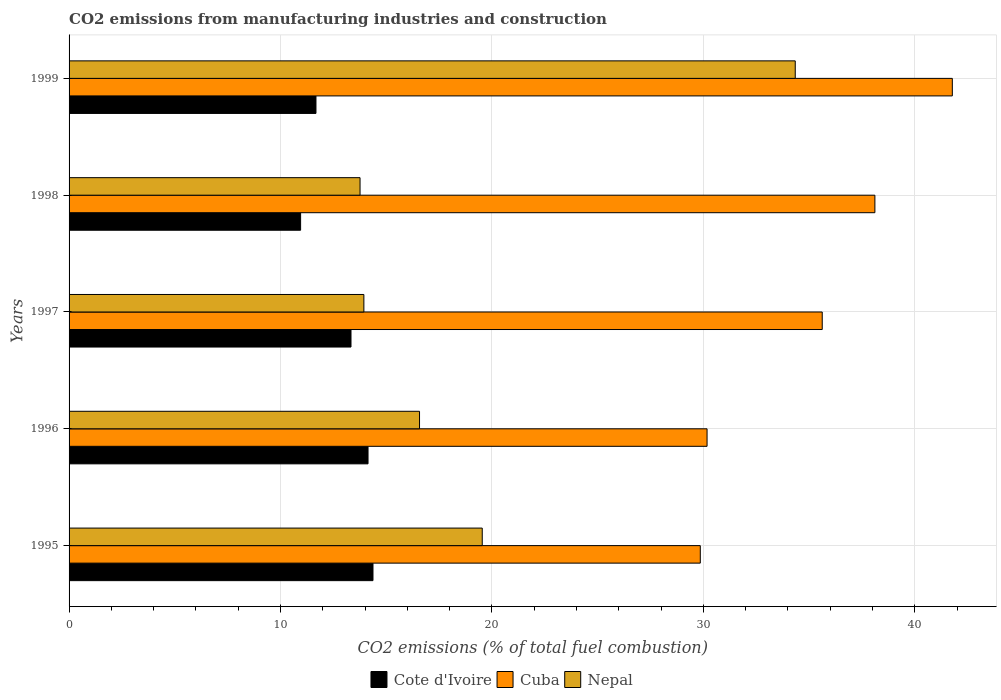How many groups of bars are there?
Give a very brief answer. 5. How many bars are there on the 3rd tick from the top?
Offer a very short reply. 3. What is the label of the 5th group of bars from the top?
Provide a succinct answer. 1995. In how many cases, is the number of bars for a given year not equal to the number of legend labels?
Provide a short and direct response. 0. What is the amount of CO2 emitted in Nepal in 1997?
Keep it short and to the point. 13.94. Across all years, what is the maximum amount of CO2 emitted in Cuba?
Provide a succinct answer. 41.77. Across all years, what is the minimum amount of CO2 emitted in Cote d'Ivoire?
Ensure brevity in your answer.  10.95. In which year was the amount of CO2 emitted in Cuba minimum?
Offer a terse response. 1995. What is the total amount of CO2 emitted in Cuba in the graph?
Provide a succinct answer. 175.53. What is the difference between the amount of CO2 emitted in Cote d'Ivoire in 1996 and that in 1999?
Provide a succinct answer. 2.46. What is the difference between the amount of CO2 emitted in Cuba in 1997 and the amount of CO2 emitted in Nepal in 1995?
Keep it short and to the point. 16.08. What is the average amount of CO2 emitted in Cote d'Ivoire per year?
Make the answer very short. 12.89. In the year 1995, what is the difference between the amount of CO2 emitted in Nepal and amount of CO2 emitted in Cote d'Ivoire?
Offer a terse response. 5.17. What is the ratio of the amount of CO2 emitted in Nepal in 1998 to that in 1999?
Offer a terse response. 0.4. Is the amount of CO2 emitted in Cuba in 1996 less than that in 1997?
Ensure brevity in your answer.  Yes. What is the difference between the highest and the second highest amount of CO2 emitted in Cuba?
Offer a very short reply. 3.66. What is the difference between the highest and the lowest amount of CO2 emitted in Nepal?
Provide a succinct answer. 20.58. Is the sum of the amount of CO2 emitted in Cote d'Ivoire in 1995 and 1999 greater than the maximum amount of CO2 emitted in Nepal across all years?
Provide a succinct answer. No. What does the 2nd bar from the top in 1996 represents?
Ensure brevity in your answer.  Cuba. What does the 2nd bar from the bottom in 1996 represents?
Offer a very short reply. Cuba. How many years are there in the graph?
Your answer should be very brief. 5. What is the difference between two consecutive major ticks on the X-axis?
Offer a very short reply. 10. Where does the legend appear in the graph?
Your response must be concise. Bottom center. How are the legend labels stacked?
Offer a very short reply. Horizontal. What is the title of the graph?
Keep it short and to the point. CO2 emissions from manufacturing industries and construction. Does "Tuvalu" appear as one of the legend labels in the graph?
Offer a terse response. No. What is the label or title of the X-axis?
Ensure brevity in your answer.  CO2 emissions (% of total fuel combustion). What is the CO2 emissions (% of total fuel combustion) of Cote d'Ivoire in 1995?
Offer a terse response. 14.37. What is the CO2 emissions (% of total fuel combustion) in Cuba in 1995?
Provide a short and direct response. 29.85. What is the CO2 emissions (% of total fuel combustion) of Nepal in 1995?
Your response must be concise. 19.54. What is the CO2 emissions (% of total fuel combustion) of Cote d'Ivoire in 1996?
Provide a succinct answer. 14.14. What is the CO2 emissions (% of total fuel combustion) of Cuba in 1996?
Provide a succinct answer. 30.17. What is the CO2 emissions (% of total fuel combustion) of Nepal in 1996?
Provide a succinct answer. 16.57. What is the CO2 emissions (% of total fuel combustion) in Cote d'Ivoire in 1997?
Offer a terse response. 13.33. What is the CO2 emissions (% of total fuel combustion) in Cuba in 1997?
Provide a short and direct response. 35.62. What is the CO2 emissions (% of total fuel combustion) in Nepal in 1997?
Your answer should be very brief. 13.94. What is the CO2 emissions (% of total fuel combustion) of Cote d'Ivoire in 1998?
Offer a very short reply. 10.95. What is the CO2 emissions (% of total fuel combustion) of Cuba in 1998?
Offer a terse response. 38.11. What is the CO2 emissions (% of total fuel combustion) of Nepal in 1998?
Provide a short and direct response. 13.76. What is the CO2 emissions (% of total fuel combustion) in Cote d'Ivoire in 1999?
Provide a succinct answer. 11.68. What is the CO2 emissions (% of total fuel combustion) of Cuba in 1999?
Your answer should be very brief. 41.77. What is the CO2 emissions (% of total fuel combustion) of Nepal in 1999?
Offer a very short reply. 34.34. Across all years, what is the maximum CO2 emissions (% of total fuel combustion) of Cote d'Ivoire?
Offer a very short reply. 14.37. Across all years, what is the maximum CO2 emissions (% of total fuel combustion) of Cuba?
Keep it short and to the point. 41.77. Across all years, what is the maximum CO2 emissions (% of total fuel combustion) of Nepal?
Provide a succinct answer. 34.34. Across all years, what is the minimum CO2 emissions (% of total fuel combustion) of Cote d'Ivoire?
Provide a succinct answer. 10.95. Across all years, what is the minimum CO2 emissions (% of total fuel combustion) of Cuba?
Ensure brevity in your answer.  29.85. Across all years, what is the minimum CO2 emissions (% of total fuel combustion) in Nepal?
Make the answer very short. 13.76. What is the total CO2 emissions (% of total fuel combustion) of Cote d'Ivoire in the graph?
Give a very brief answer. 64.47. What is the total CO2 emissions (% of total fuel combustion) of Cuba in the graph?
Offer a very short reply. 175.53. What is the total CO2 emissions (% of total fuel combustion) in Nepal in the graph?
Offer a terse response. 98.16. What is the difference between the CO2 emissions (% of total fuel combustion) of Cote d'Ivoire in 1995 and that in 1996?
Your answer should be very brief. 0.23. What is the difference between the CO2 emissions (% of total fuel combustion) of Cuba in 1995 and that in 1996?
Provide a succinct answer. -0.32. What is the difference between the CO2 emissions (% of total fuel combustion) of Nepal in 1995 and that in 1996?
Provide a succinct answer. 2.97. What is the difference between the CO2 emissions (% of total fuel combustion) in Cote d'Ivoire in 1995 and that in 1997?
Your answer should be very brief. 1.04. What is the difference between the CO2 emissions (% of total fuel combustion) in Cuba in 1995 and that in 1997?
Provide a short and direct response. -5.77. What is the difference between the CO2 emissions (% of total fuel combustion) in Nepal in 1995 and that in 1997?
Ensure brevity in your answer.  5.6. What is the difference between the CO2 emissions (% of total fuel combustion) of Cote d'Ivoire in 1995 and that in 1998?
Offer a terse response. 3.42. What is the difference between the CO2 emissions (% of total fuel combustion) in Cuba in 1995 and that in 1998?
Provide a short and direct response. -8.26. What is the difference between the CO2 emissions (% of total fuel combustion) in Nepal in 1995 and that in 1998?
Ensure brevity in your answer.  5.78. What is the difference between the CO2 emissions (% of total fuel combustion) of Cote d'Ivoire in 1995 and that in 1999?
Give a very brief answer. 2.7. What is the difference between the CO2 emissions (% of total fuel combustion) of Cuba in 1995 and that in 1999?
Your answer should be compact. -11.92. What is the difference between the CO2 emissions (% of total fuel combustion) of Nepal in 1995 and that in 1999?
Keep it short and to the point. -14.8. What is the difference between the CO2 emissions (% of total fuel combustion) of Cote d'Ivoire in 1996 and that in 1997?
Your response must be concise. 0.81. What is the difference between the CO2 emissions (% of total fuel combustion) in Cuba in 1996 and that in 1997?
Give a very brief answer. -5.45. What is the difference between the CO2 emissions (% of total fuel combustion) in Nepal in 1996 and that in 1997?
Your answer should be very brief. 2.63. What is the difference between the CO2 emissions (% of total fuel combustion) in Cote d'Ivoire in 1996 and that in 1998?
Provide a short and direct response. 3.19. What is the difference between the CO2 emissions (% of total fuel combustion) in Cuba in 1996 and that in 1998?
Give a very brief answer. -7.94. What is the difference between the CO2 emissions (% of total fuel combustion) of Nepal in 1996 and that in 1998?
Provide a short and direct response. 2.81. What is the difference between the CO2 emissions (% of total fuel combustion) of Cote d'Ivoire in 1996 and that in 1999?
Provide a succinct answer. 2.46. What is the difference between the CO2 emissions (% of total fuel combustion) of Cuba in 1996 and that in 1999?
Offer a very short reply. -11.6. What is the difference between the CO2 emissions (% of total fuel combustion) in Nepal in 1996 and that in 1999?
Keep it short and to the point. -17.77. What is the difference between the CO2 emissions (% of total fuel combustion) in Cote d'Ivoire in 1997 and that in 1998?
Give a very brief answer. 2.38. What is the difference between the CO2 emissions (% of total fuel combustion) in Cuba in 1997 and that in 1998?
Provide a succinct answer. -2.49. What is the difference between the CO2 emissions (% of total fuel combustion) in Nepal in 1997 and that in 1998?
Offer a very short reply. 0.18. What is the difference between the CO2 emissions (% of total fuel combustion) in Cote d'Ivoire in 1997 and that in 1999?
Your answer should be compact. 1.66. What is the difference between the CO2 emissions (% of total fuel combustion) in Cuba in 1997 and that in 1999?
Keep it short and to the point. -6.15. What is the difference between the CO2 emissions (% of total fuel combustion) of Nepal in 1997 and that in 1999?
Make the answer very short. -20.4. What is the difference between the CO2 emissions (% of total fuel combustion) in Cote d'Ivoire in 1998 and that in 1999?
Keep it short and to the point. -0.73. What is the difference between the CO2 emissions (% of total fuel combustion) of Cuba in 1998 and that in 1999?
Keep it short and to the point. -3.66. What is the difference between the CO2 emissions (% of total fuel combustion) in Nepal in 1998 and that in 1999?
Your response must be concise. -20.58. What is the difference between the CO2 emissions (% of total fuel combustion) in Cote d'Ivoire in 1995 and the CO2 emissions (% of total fuel combustion) in Cuba in 1996?
Offer a terse response. -15.8. What is the difference between the CO2 emissions (% of total fuel combustion) of Cote d'Ivoire in 1995 and the CO2 emissions (% of total fuel combustion) of Nepal in 1996?
Offer a terse response. -2.2. What is the difference between the CO2 emissions (% of total fuel combustion) of Cuba in 1995 and the CO2 emissions (% of total fuel combustion) of Nepal in 1996?
Keep it short and to the point. 13.28. What is the difference between the CO2 emissions (% of total fuel combustion) of Cote d'Ivoire in 1995 and the CO2 emissions (% of total fuel combustion) of Cuba in 1997?
Your response must be concise. -21.25. What is the difference between the CO2 emissions (% of total fuel combustion) of Cote d'Ivoire in 1995 and the CO2 emissions (% of total fuel combustion) of Nepal in 1997?
Make the answer very short. 0.43. What is the difference between the CO2 emissions (% of total fuel combustion) of Cuba in 1995 and the CO2 emissions (% of total fuel combustion) of Nepal in 1997?
Provide a short and direct response. 15.91. What is the difference between the CO2 emissions (% of total fuel combustion) in Cote d'Ivoire in 1995 and the CO2 emissions (% of total fuel combustion) in Cuba in 1998?
Offer a terse response. -23.74. What is the difference between the CO2 emissions (% of total fuel combustion) in Cote d'Ivoire in 1995 and the CO2 emissions (% of total fuel combustion) in Nepal in 1998?
Your answer should be compact. 0.61. What is the difference between the CO2 emissions (% of total fuel combustion) in Cuba in 1995 and the CO2 emissions (% of total fuel combustion) in Nepal in 1998?
Ensure brevity in your answer.  16.09. What is the difference between the CO2 emissions (% of total fuel combustion) in Cote d'Ivoire in 1995 and the CO2 emissions (% of total fuel combustion) in Cuba in 1999?
Offer a very short reply. -27.4. What is the difference between the CO2 emissions (% of total fuel combustion) in Cote d'Ivoire in 1995 and the CO2 emissions (% of total fuel combustion) in Nepal in 1999?
Provide a succinct answer. -19.97. What is the difference between the CO2 emissions (% of total fuel combustion) in Cuba in 1995 and the CO2 emissions (% of total fuel combustion) in Nepal in 1999?
Ensure brevity in your answer.  -4.49. What is the difference between the CO2 emissions (% of total fuel combustion) in Cote d'Ivoire in 1996 and the CO2 emissions (% of total fuel combustion) in Cuba in 1997?
Your answer should be very brief. -21.48. What is the difference between the CO2 emissions (% of total fuel combustion) of Cote d'Ivoire in 1996 and the CO2 emissions (% of total fuel combustion) of Nepal in 1997?
Your answer should be compact. 0.2. What is the difference between the CO2 emissions (% of total fuel combustion) in Cuba in 1996 and the CO2 emissions (% of total fuel combustion) in Nepal in 1997?
Provide a succinct answer. 16.23. What is the difference between the CO2 emissions (% of total fuel combustion) in Cote d'Ivoire in 1996 and the CO2 emissions (% of total fuel combustion) in Cuba in 1998?
Provide a succinct answer. -23.97. What is the difference between the CO2 emissions (% of total fuel combustion) in Cote d'Ivoire in 1996 and the CO2 emissions (% of total fuel combustion) in Nepal in 1998?
Make the answer very short. 0.38. What is the difference between the CO2 emissions (% of total fuel combustion) in Cuba in 1996 and the CO2 emissions (% of total fuel combustion) in Nepal in 1998?
Offer a terse response. 16.41. What is the difference between the CO2 emissions (% of total fuel combustion) in Cote d'Ivoire in 1996 and the CO2 emissions (% of total fuel combustion) in Cuba in 1999?
Offer a very short reply. -27.63. What is the difference between the CO2 emissions (% of total fuel combustion) of Cote d'Ivoire in 1996 and the CO2 emissions (% of total fuel combustion) of Nepal in 1999?
Your answer should be very brief. -20.2. What is the difference between the CO2 emissions (% of total fuel combustion) of Cuba in 1996 and the CO2 emissions (% of total fuel combustion) of Nepal in 1999?
Your answer should be very brief. -4.17. What is the difference between the CO2 emissions (% of total fuel combustion) in Cote d'Ivoire in 1997 and the CO2 emissions (% of total fuel combustion) in Cuba in 1998?
Ensure brevity in your answer.  -24.78. What is the difference between the CO2 emissions (% of total fuel combustion) in Cote d'Ivoire in 1997 and the CO2 emissions (% of total fuel combustion) in Nepal in 1998?
Offer a terse response. -0.43. What is the difference between the CO2 emissions (% of total fuel combustion) in Cuba in 1997 and the CO2 emissions (% of total fuel combustion) in Nepal in 1998?
Make the answer very short. 21.86. What is the difference between the CO2 emissions (% of total fuel combustion) of Cote d'Ivoire in 1997 and the CO2 emissions (% of total fuel combustion) of Cuba in 1999?
Your answer should be compact. -28.44. What is the difference between the CO2 emissions (% of total fuel combustion) in Cote d'Ivoire in 1997 and the CO2 emissions (% of total fuel combustion) in Nepal in 1999?
Give a very brief answer. -21.01. What is the difference between the CO2 emissions (% of total fuel combustion) of Cuba in 1997 and the CO2 emissions (% of total fuel combustion) of Nepal in 1999?
Provide a succinct answer. 1.28. What is the difference between the CO2 emissions (% of total fuel combustion) in Cote d'Ivoire in 1998 and the CO2 emissions (% of total fuel combustion) in Cuba in 1999?
Offer a terse response. -30.82. What is the difference between the CO2 emissions (% of total fuel combustion) in Cote d'Ivoire in 1998 and the CO2 emissions (% of total fuel combustion) in Nepal in 1999?
Keep it short and to the point. -23.39. What is the difference between the CO2 emissions (% of total fuel combustion) of Cuba in 1998 and the CO2 emissions (% of total fuel combustion) of Nepal in 1999?
Ensure brevity in your answer.  3.77. What is the average CO2 emissions (% of total fuel combustion) of Cote d'Ivoire per year?
Provide a short and direct response. 12.89. What is the average CO2 emissions (% of total fuel combustion) of Cuba per year?
Provide a succinct answer. 35.11. What is the average CO2 emissions (% of total fuel combustion) in Nepal per year?
Make the answer very short. 19.63. In the year 1995, what is the difference between the CO2 emissions (% of total fuel combustion) of Cote d'Ivoire and CO2 emissions (% of total fuel combustion) of Cuba?
Make the answer very short. -15.48. In the year 1995, what is the difference between the CO2 emissions (% of total fuel combustion) of Cote d'Ivoire and CO2 emissions (% of total fuel combustion) of Nepal?
Provide a short and direct response. -5.17. In the year 1995, what is the difference between the CO2 emissions (% of total fuel combustion) in Cuba and CO2 emissions (% of total fuel combustion) in Nepal?
Your answer should be compact. 10.31. In the year 1996, what is the difference between the CO2 emissions (% of total fuel combustion) in Cote d'Ivoire and CO2 emissions (% of total fuel combustion) in Cuba?
Give a very brief answer. -16.03. In the year 1996, what is the difference between the CO2 emissions (% of total fuel combustion) in Cote d'Ivoire and CO2 emissions (% of total fuel combustion) in Nepal?
Ensure brevity in your answer.  -2.44. In the year 1996, what is the difference between the CO2 emissions (% of total fuel combustion) of Cuba and CO2 emissions (% of total fuel combustion) of Nepal?
Keep it short and to the point. 13.6. In the year 1997, what is the difference between the CO2 emissions (% of total fuel combustion) in Cote d'Ivoire and CO2 emissions (% of total fuel combustion) in Cuba?
Offer a terse response. -22.29. In the year 1997, what is the difference between the CO2 emissions (% of total fuel combustion) of Cote d'Ivoire and CO2 emissions (% of total fuel combustion) of Nepal?
Make the answer very short. -0.61. In the year 1997, what is the difference between the CO2 emissions (% of total fuel combustion) in Cuba and CO2 emissions (% of total fuel combustion) in Nepal?
Your response must be concise. 21.68. In the year 1998, what is the difference between the CO2 emissions (% of total fuel combustion) of Cote d'Ivoire and CO2 emissions (% of total fuel combustion) of Cuba?
Your answer should be compact. -27.16. In the year 1998, what is the difference between the CO2 emissions (% of total fuel combustion) of Cote d'Ivoire and CO2 emissions (% of total fuel combustion) of Nepal?
Make the answer very short. -2.81. In the year 1998, what is the difference between the CO2 emissions (% of total fuel combustion) in Cuba and CO2 emissions (% of total fuel combustion) in Nepal?
Your answer should be very brief. 24.35. In the year 1999, what is the difference between the CO2 emissions (% of total fuel combustion) of Cote d'Ivoire and CO2 emissions (% of total fuel combustion) of Cuba?
Offer a very short reply. -30.1. In the year 1999, what is the difference between the CO2 emissions (% of total fuel combustion) of Cote d'Ivoire and CO2 emissions (% of total fuel combustion) of Nepal?
Provide a short and direct response. -22.67. In the year 1999, what is the difference between the CO2 emissions (% of total fuel combustion) of Cuba and CO2 emissions (% of total fuel combustion) of Nepal?
Offer a very short reply. 7.43. What is the ratio of the CO2 emissions (% of total fuel combustion) in Cote d'Ivoire in 1995 to that in 1996?
Offer a very short reply. 1.02. What is the ratio of the CO2 emissions (% of total fuel combustion) of Nepal in 1995 to that in 1996?
Offer a terse response. 1.18. What is the ratio of the CO2 emissions (% of total fuel combustion) of Cote d'Ivoire in 1995 to that in 1997?
Keep it short and to the point. 1.08. What is the ratio of the CO2 emissions (% of total fuel combustion) of Cuba in 1995 to that in 1997?
Offer a very short reply. 0.84. What is the ratio of the CO2 emissions (% of total fuel combustion) of Nepal in 1995 to that in 1997?
Make the answer very short. 1.4. What is the ratio of the CO2 emissions (% of total fuel combustion) in Cote d'Ivoire in 1995 to that in 1998?
Offer a very short reply. 1.31. What is the ratio of the CO2 emissions (% of total fuel combustion) of Cuba in 1995 to that in 1998?
Make the answer very short. 0.78. What is the ratio of the CO2 emissions (% of total fuel combustion) of Nepal in 1995 to that in 1998?
Provide a succinct answer. 1.42. What is the ratio of the CO2 emissions (% of total fuel combustion) in Cote d'Ivoire in 1995 to that in 1999?
Make the answer very short. 1.23. What is the ratio of the CO2 emissions (% of total fuel combustion) of Cuba in 1995 to that in 1999?
Offer a very short reply. 0.71. What is the ratio of the CO2 emissions (% of total fuel combustion) of Nepal in 1995 to that in 1999?
Your answer should be compact. 0.57. What is the ratio of the CO2 emissions (% of total fuel combustion) of Cote d'Ivoire in 1996 to that in 1997?
Keep it short and to the point. 1.06. What is the ratio of the CO2 emissions (% of total fuel combustion) of Cuba in 1996 to that in 1997?
Offer a very short reply. 0.85. What is the ratio of the CO2 emissions (% of total fuel combustion) of Nepal in 1996 to that in 1997?
Your response must be concise. 1.19. What is the ratio of the CO2 emissions (% of total fuel combustion) of Cote d'Ivoire in 1996 to that in 1998?
Your answer should be compact. 1.29. What is the ratio of the CO2 emissions (% of total fuel combustion) in Cuba in 1996 to that in 1998?
Keep it short and to the point. 0.79. What is the ratio of the CO2 emissions (% of total fuel combustion) of Nepal in 1996 to that in 1998?
Your response must be concise. 1.2. What is the ratio of the CO2 emissions (% of total fuel combustion) in Cote d'Ivoire in 1996 to that in 1999?
Provide a short and direct response. 1.21. What is the ratio of the CO2 emissions (% of total fuel combustion) in Cuba in 1996 to that in 1999?
Give a very brief answer. 0.72. What is the ratio of the CO2 emissions (% of total fuel combustion) of Nepal in 1996 to that in 1999?
Keep it short and to the point. 0.48. What is the ratio of the CO2 emissions (% of total fuel combustion) of Cote d'Ivoire in 1997 to that in 1998?
Give a very brief answer. 1.22. What is the ratio of the CO2 emissions (% of total fuel combustion) in Cuba in 1997 to that in 1998?
Give a very brief answer. 0.93. What is the ratio of the CO2 emissions (% of total fuel combustion) of Nepal in 1997 to that in 1998?
Your answer should be very brief. 1.01. What is the ratio of the CO2 emissions (% of total fuel combustion) of Cote d'Ivoire in 1997 to that in 1999?
Give a very brief answer. 1.14. What is the ratio of the CO2 emissions (% of total fuel combustion) of Cuba in 1997 to that in 1999?
Offer a very short reply. 0.85. What is the ratio of the CO2 emissions (% of total fuel combustion) in Nepal in 1997 to that in 1999?
Give a very brief answer. 0.41. What is the ratio of the CO2 emissions (% of total fuel combustion) in Cote d'Ivoire in 1998 to that in 1999?
Give a very brief answer. 0.94. What is the ratio of the CO2 emissions (% of total fuel combustion) in Cuba in 1998 to that in 1999?
Give a very brief answer. 0.91. What is the ratio of the CO2 emissions (% of total fuel combustion) in Nepal in 1998 to that in 1999?
Offer a terse response. 0.4. What is the difference between the highest and the second highest CO2 emissions (% of total fuel combustion) in Cote d'Ivoire?
Your response must be concise. 0.23. What is the difference between the highest and the second highest CO2 emissions (% of total fuel combustion) of Cuba?
Ensure brevity in your answer.  3.66. What is the difference between the highest and the second highest CO2 emissions (% of total fuel combustion) in Nepal?
Make the answer very short. 14.8. What is the difference between the highest and the lowest CO2 emissions (% of total fuel combustion) in Cote d'Ivoire?
Your answer should be very brief. 3.42. What is the difference between the highest and the lowest CO2 emissions (% of total fuel combustion) in Cuba?
Your answer should be compact. 11.92. What is the difference between the highest and the lowest CO2 emissions (% of total fuel combustion) of Nepal?
Your answer should be very brief. 20.58. 